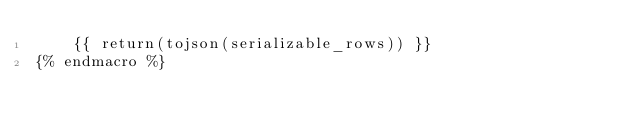<code> <loc_0><loc_0><loc_500><loc_500><_SQL_>    {{ return(tojson(serializable_rows)) }}
{% endmacro %}</code> 